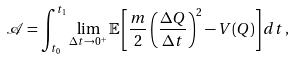<formula> <loc_0><loc_0><loc_500><loc_500>\mathcal { A } = \int _ { t _ { 0 } } ^ { t _ { 1 } } \lim _ { \Delta t \rightarrow 0 ^ { + } } \mathbb { E } \left [ \frac { m } { 2 } \left ( \frac { \Delta Q } { \Delta t } \right ) ^ { 2 } - V ( Q ) \right ] d t \, ,</formula> 